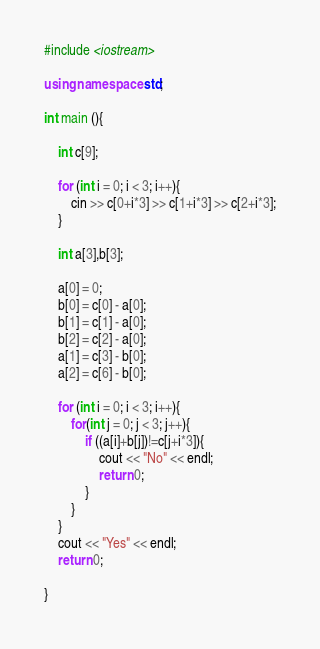Convert code to text. <code><loc_0><loc_0><loc_500><loc_500><_C++_>#include <iostream>

using namespace std;

int main (){

    int c[9];

    for (int i = 0; i < 3; i++){
        cin >> c[0+i*3] >> c[1+i*3] >> c[2+i*3];
    }

    int a[3],b[3];

    a[0] = 0;
    b[0] = c[0] - a[0];
    b[1] = c[1] - a[0];
    b[2] = c[2] - a[0];
    a[1] = c[3] - b[0];
    a[2] = c[6] - b[0];

    for (int i = 0; i < 3; i++){
        for(int j = 0; j < 3; j++){
            if ((a[i]+b[j])!=c[j+i*3]){
                cout << "No" << endl;
                return 0;
            }
        }
    }
    cout << "Yes" << endl;    
    return 0;

}</code> 